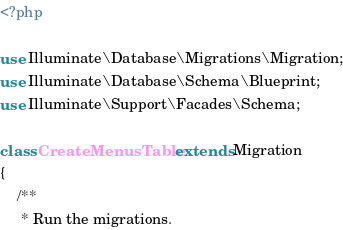<code> <loc_0><loc_0><loc_500><loc_500><_PHP_><?php

use Illuminate\Database\Migrations\Migration;
use Illuminate\Database\Schema\Blueprint;
use Illuminate\Support\Facades\Schema;

class CreateMenusTable extends Migration
{
    /**
     * Run the migrations.</code> 